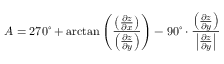Convert formula to latex. <formula><loc_0><loc_0><loc_500><loc_500>A = 2 7 0 ^ { \circ } + \arctan \left ( { \frac { \left ( { \frac { \partial z } { \partial x } } \right ) } { \left ( { \frac { \partial z } { \partial y } } \right ) } } \right ) - 9 0 ^ { \circ } \cdot { \frac { \left ( { \frac { \partial z } { \partial y } } \right ) } { \left | { \frac { \partial z } { \partial y } } \right | } }</formula> 